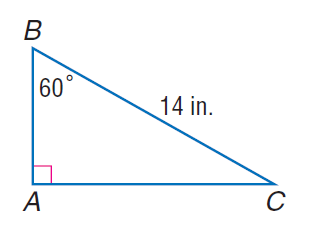Answer the mathemtical geometry problem and directly provide the correct option letter.
Question: Find A C.
Choices: A: 7 B: 7 \sqrt { 3 } C: 14 D: 14 \sqrt { 3 } B 